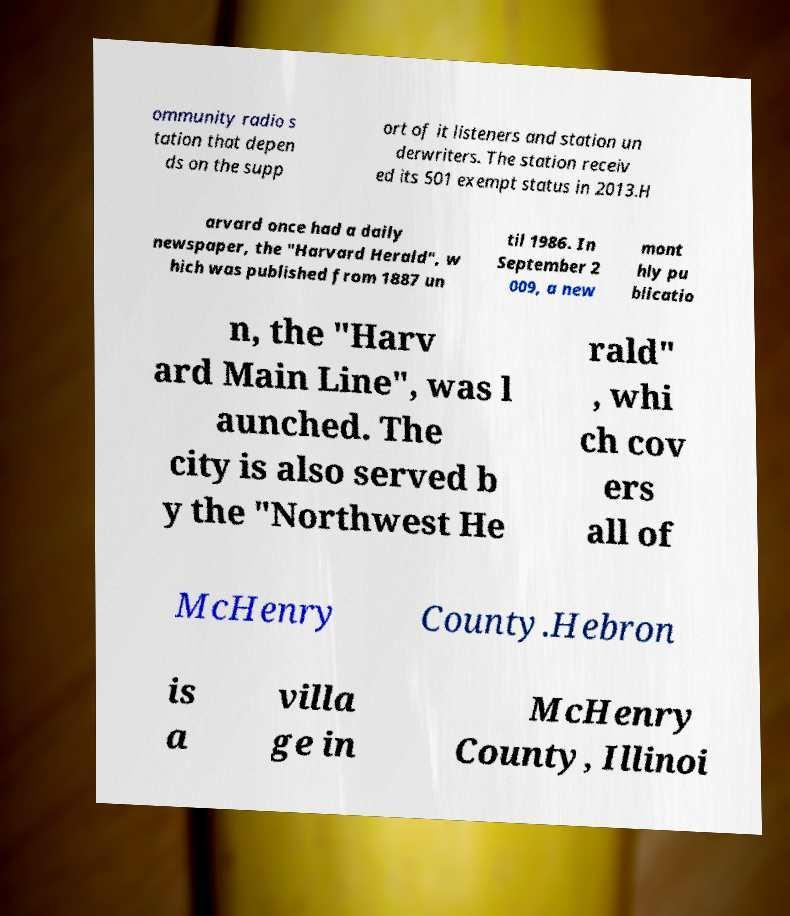I need the written content from this picture converted into text. Can you do that? ommunity radio s tation that depen ds on the supp ort of it listeners and station un derwriters. The station receiv ed its 501 exempt status in 2013.H arvard once had a daily newspaper, the "Harvard Herald", w hich was published from 1887 un til 1986. In September 2 009, a new mont hly pu blicatio n, the "Harv ard Main Line", was l aunched. The city is also served b y the "Northwest He rald" , whi ch cov ers all of McHenry County.Hebron is a villa ge in McHenry County, Illinoi 